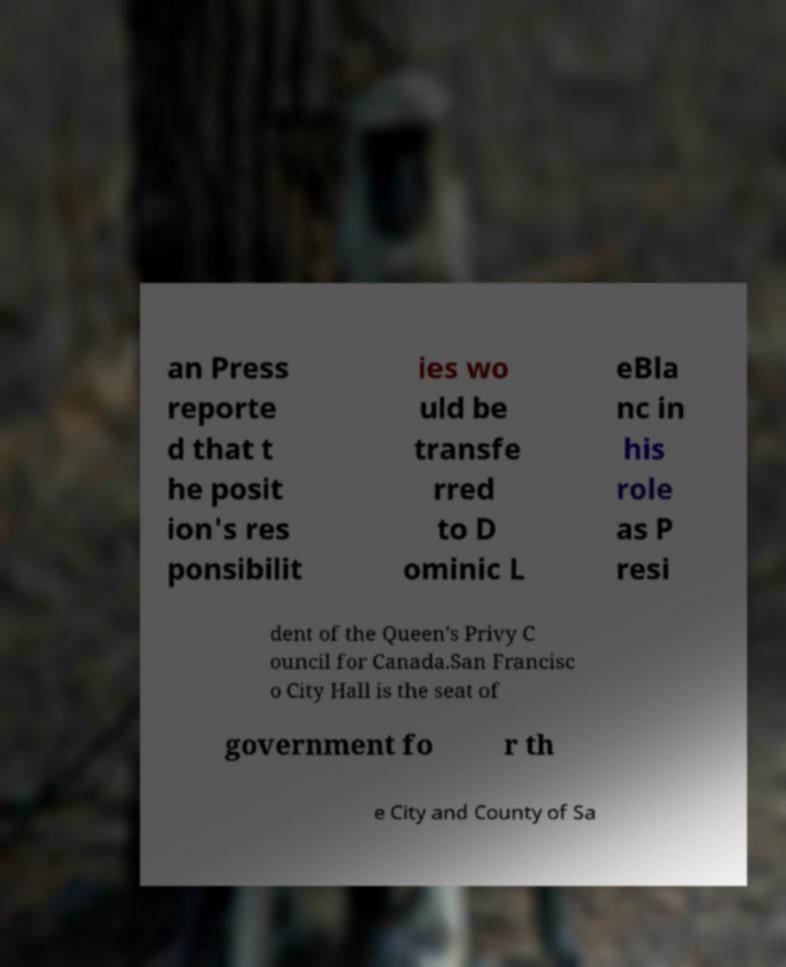Can you accurately transcribe the text from the provided image for me? an Press reporte d that t he posit ion's res ponsibilit ies wo uld be transfe rred to D ominic L eBla nc in his role as P resi dent of the Queen's Privy C ouncil for Canada.San Francisc o City Hall is the seat of government fo r th e City and County of Sa 